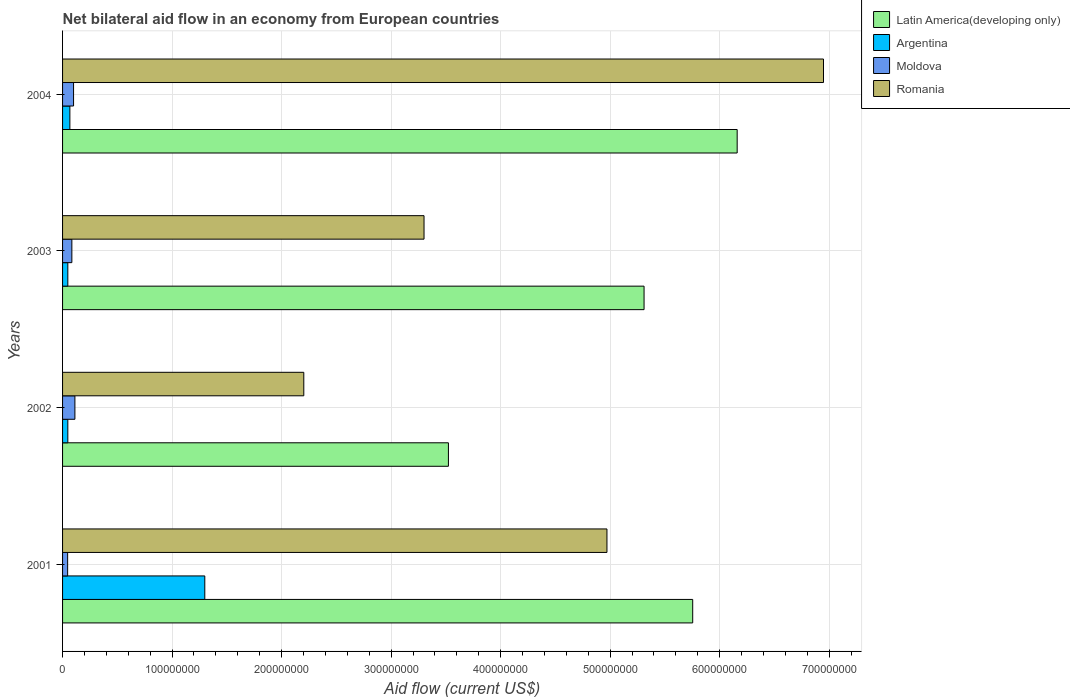How many groups of bars are there?
Offer a terse response. 4. Are the number of bars per tick equal to the number of legend labels?
Give a very brief answer. Yes. Are the number of bars on each tick of the Y-axis equal?
Offer a terse response. Yes. How many bars are there on the 1st tick from the top?
Give a very brief answer. 4. How many bars are there on the 3rd tick from the bottom?
Your answer should be compact. 4. In how many cases, is the number of bars for a given year not equal to the number of legend labels?
Make the answer very short. 0. What is the net bilateral aid flow in Romania in 2004?
Keep it short and to the point. 6.95e+08. Across all years, what is the maximum net bilateral aid flow in Romania?
Ensure brevity in your answer.  6.95e+08. Across all years, what is the minimum net bilateral aid flow in Moldova?
Ensure brevity in your answer.  4.64e+06. In which year was the net bilateral aid flow in Argentina minimum?
Offer a very short reply. 2002. What is the total net bilateral aid flow in Romania in the graph?
Your answer should be very brief. 1.74e+09. What is the difference between the net bilateral aid flow in Latin America(developing only) in 2001 and that in 2004?
Ensure brevity in your answer.  -4.06e+07. What is the difference between the net bilateral aid flow in Latin America(developing only) in 2004 and the net bilateral aid flow in Moldova in 2003?
Your response must be concise. 6.07e+08. What is the average net bilateral aid flow in Moldova per year?
Your answer should be very brief. 8.61e+06. In the year 2003, what is the difference between the net bilateral aid flow in Romania and net bilateral aid flow in Moldova?
Give a very brief answer. 3.22e+08. In how many years, is the net bilateral aid flow in Argentina greater than 560000000 US$?
Make the answer very short. 0. What is the ratio of the net bilateral aid flow in Argentina in 2002 to that in 2004?
Your response must be concise. 0.72. Is the net bilateral aid flow in Moldova in 2001 less than that in 2002?
Your answer should be compact. Yes. What is the difference between the highest and the second highest net bilateral aid flow in Latin America(developing only)?
Offer a very short reply. 4.06e+07. What is the difference between the highest and the lowest net bilateral aid flow in Moldova?
Make the answer very short. 6.63e+06. In how many years, is the net bilateral aid flow in Moldova greater than the average net bilateral aid flow in Moldova taken over all years?
Offer a terse response. 2. Is the sum of the net bilateral aid flow in Moldova in 2001 and 2003 greater than the maximum net bilateral aid flow in Romania across all years?
Offer a very short reply. No. What does the 2nd bar from the top in 2003 represents?
Your answer should be very brief. Moldova. What does the 3rd bar from the bottom in 2003 represents?
Keep it short and to the point. Moldova. Does the graph contain any zero values?
Make the answer very short. No. How are the legend labels stacked?
Your answer should be very brief. Vertical. What is the title of the graph?
Your answer should be very brief. Net bilateral aid flow in an economy from European countries. Does "Middle East & North Africa (developing only)" appear as one of the legend labels in the graph?
Offer a terse response. No. What is the label or title of the Y-axis?
Provide a short and direct response. Years. What is the Aid flow (current US$) in Latin America(developing only) in 2001?
Give a very brief answer. 5.75e+08. What is the Aid flow (current US$) of Argentina in 2001?
Your answer should be very brief. 1.30e+08. What is the Aid flow (current US$) of Moldova in 2001?
Make the answer very short. 4.64e+06. What is the Aid flow (current US$) in Romania in 2001?
Offer a terse response. 4.97e+08. What is the Aid flow (current US$) in Latin America(developing only) in 2002?
Your answer should be compact. 3.52e+08. What is the Aid flow (current US$) of Argentina in 2002?
Offer a very short reply. 4.80e+06. What is the Aid flow (current US$) in Moldova in 2002?
Provide a short and direct response. 1.13e+07. What is the Aid flow (current US$) of Romania in 2002?
Your response must be concise. 2.20e+08. What is the Aid flow (current US$) of Latin America(developing only) in 2003?
Provide a short and direct response. 5.31e+08. What is the Aid flow (current US$) in Argentina in 2003?
Ensure brevity in your answer.  4.81e+06. What is the Aid flow (current US$) in Moldova in 2003?
Provide a short and direct response. 8.48e+06. What is the Aid flow (current US$) in Romania in 2003?
Your answer should be very brief. 3.30e+08. What is the Aid flow (current US$) of Latin America(developing only) in 2004?
Offer a terse response. 6.16e+08. What is the Aid flow (current US$) in Argentina in 2004?
Provide a succinct answer. 6.68e+06. What is the Aid flow (current US$) of Moldova in 2004?
Keep it short and to the point. 1.00e+07. What is the Aid flow (current US$) in Romania in 2004?
Offer a terse response. 6.95e+08. Across all years, what is the maximum Aid flow (current US$) of Latin America(developing only)?
Offer a terse response. 6.16e+08. Across all years, what is the maximum Aid flow (current US$) of Argentina?
Ensure brevity in your answer.  1.30e+08. Across all years, what is the maximum Aid flow (current US$) of Moldova?
Make the answer very short. 1.13e+07. Across all years, what is the maximum Aid flow (current US$) in Romania?
Ensure brevity in your answer.  6.95e+08. Across all years, what is the minimum Aid flow (current US$) of Latin America(developing only)?
Make the answer very short. 3.52e+08. Across all years, what is the minimum Aid flow (current US$) of Argentina?
Give a very brief answer. 4.80e+06. Across all years, what is the minimum Aid flow (current US$) in Moldova?
Make the answer very short. 4.64e+06. Across all years, what is the minimum Aid flow (current US$) in Romania?
Offer a very short reply. 2.20e+08. What is the total Aid flow (current US$) in Latin America(developing only) in the graph?
Give a very brief answer. 2.07e+09. What is the total Aid flow (current US$) of Argentina in the graph?
Make the answer very short. 1.46e+08. What is the total Aid flow (current US$) of Moldova in the graph?
Your answer should be compact. 3.44e+07. What is the total Aid flow (current US$) of Romania in the graph?
Ensure brevity in your answer.  1.74e+09. What is the difference between the Aid flow (current US$) in Latin America(developing only) in 2001 and that in 2002?
Keep it short and to the point. 2.23e+08. What is the difference between the Aid flow (current US$) in Argentina in 2001 and that in 2002?
Offer a very short reply. 1.25e+08. What is the difference between the Aid flow (current US$) in Moldova in 2001 and that in 2002?
Provide a short and direct response. -6.63e+06. What is the difference between the Aid flow (current US$) of Romania in 2001 and that in 2002?
Give a very brief answer. 2.77e+08. What is the difference between the Aid flow (current US$) in Latin America(developing only) in 2001 and that in 2003?
Give a very brief answer. 4.44e+07. What is the difference between the Aid flow (current US$) in Argentina in 2001 and that in 2003?
Offer a terse response. 1.25e+08. What is the difference between the Aid flow (current US$) of Moldova in 2001 and that in 2003?
Your response must be concise. -3.84e+06. What is the difference between the Aid flow (current US$) in Romania in 2001 and that in 2003?
Your response must be concise. 1.67e+08. What is the difference between the Aid flow (current US$) in Latin America(developing only) in 2001 and that in 2004?
Your answer should be very brief. -4.06e+07. What is the difference between the Aid flow (current US$) of Argentina in 2001 and that in 2004?
Offer a very short reply. 1.23e+08. What is the difference between the Aid flow (current US$) of Moldova in 2001 and that in 2004?
Your answer should be very brief. -5.40e+06. What is the difference between the Aid flow (current US$) in Romania in 2001 and that in 2004?
Give a very brief answer. -1.98e+08. What is the difference between the Aid flow (current US$) of Latin America(developing only) in 2002 and that in 2003?
Provide a succinct answer. -1.79e+08. What is the difference between the Aid flow (current US$) of Moldova in 2002 and that in 2003?
Your answer should be compact. 2.79e+06. What is the difference between the Aid flow (current US$) of Romania in 2002 and that in 2003?
Ensure brevity in your answer.  -1.10e+08. What is the difference between the Aid flow (current US$) of Latin America(developing only) in 2002 and that in 2004?
Make the answer very short. -2.64e+08. What is the difference between the Aid flow (current US$) of Argentina in 2002 and that in 2004?
Give a very brief answer. -1.88e+06. What is the difference between the Aid flow (current US$) of Moldova in 2002 and that in 2004?
Offer a terse response. 1.23e+06. What is the difference between the Aid flow (current US$) of Romania in 2002 and that in 2004?
Keep it short and to the point. -4.75e+08. What is the difference between the Aid flow (current US$) in Latin America(developing only) in 2003 and that in 2004?
Your answer should be compact. -8.50e+07. What is the difference between the Aid flow (current US$) of Argentina in 2003 and that in 2004?
Provide a short and direct response. -1.87e+06. What is the difference between the Aid flow (current US$) of Moldova in 2003 and that in 2004?
Your answer should be very brief. -1.56e+06. What is the difference between the Aid flow (current US$) of Romania in 2003 and that in 2004?
Make the answer very short. -3.65e+08. What is the difference between the Aid flow (current US$) in Latin America(developing only) in 2001 and the Aid flow (current US$) in Argentina in 2002?
Offer a terse response. 5.71e+08. What is the difference between the Aid flow (current US$) in Latin America(developing only) in 2001 and the Aid flow (current US$) in Moldova in 2002?
Ensure brevity in your answer.  5.64e+08. What is the difference between the Aid flow (current US$) of Latin America(developing only) in 2001 and the Aid flow (current US$) of Romania in 2002?
Your answer should be very brief. 3.55e+08. What is the difference between the Aid flow (current US$) in Argentina in 2001 and the Aid flow (current US$) in Moldova in 2002?
Keep it short and to the point. 1.19e+08. What is the difference between the Aid flow (current US$) in Argentina in 2001 and the Aid flow (current US$) in Romania in 2002?
Your answer should be compact. -9.04e+07. What is the difference between the Aid flow (current US$) of Moldova in 2001 and the Aid flow (current US$) of Romania in 2002?
Offer a terse response. -2.16e+08. What is the difference between the Aid flow (current US$) of Latin America(developing only) in 2001 and the Aid flow (current US$) of Argentina in 2003?
Provide a short and direct response. 5.71e+08. What is the difference between the Aid flow (current US$) in Latin America(developing only) in 2001 and the Aid flow (current US$) in Moldova in 2003?
Your response must be concise. 5.67e+08. What is the difference between the Aid flow (current US$) in Latin America(developing only) in 2001 and the Aid flow (current US$) in Romania in 2003?
Your response must be concise. 2.45e+08. What is the difference between the Aid flow (current US$) of Argentina in 2001 and the Aid flow (current US$) of Moldova in 2003?
Give a very brief answer. 1.21e+08. What is the difference between the Aid flow (current US$) in Argentina in 2001 and the Aid flow (current US$) in Romania in 2003?
Provide a succinct answer. -2.00e+08. What is the difference between the Aid flow (current US$) of Moldova in 2001 and the Aid flow (current US$) of Romania in 2003?
Give a very brief answer. -3.25e+08. What is the difference between the Aid flow (current US$) of Latin America(developing only) in 2001 and the Aid flow (current US$) of Argentina in 2004?
Your answer should be compact. 5.69e+08. What is the difference between the Aid flow (current US$) in Latin America(developing only) in 2001 and the Aid flow (current US$) in Moldova in 2004?
Ensure brevity in your answer.  5.65e+08. What is the difference between the Aid flow (current US$) of Latin America(developing only) in 2001 and the Aid flow (current US$) of Romania in 2004?
Provide a short and direct response. -1.19e+08. What is the difference between the Aid flow (current US$) of Argentina in 2001 and the Aid flow (current US$) of Moldova in 2004?
Provide a short and direct response. 1.20e+08. What is the difference between the Aid flow (current US$) of Argentina in 2001 and the Aid flow (current US$) of Romania in 2004?
Offer a very short reply. -5.65e+08. What is the difference between the Aid flow (current US$) of Moldova in 2001 and the Aid flow (current US$) of Romania in 2004?
Your answer should be compact. -6.90e+08. What is the difference between the Aid flow (current US$) of Latin America(developing only) in 2002 and the Aid flow (current US$) of Argentina in 2003?
Provide a succinct answer. 3.48e+08. What is the difference between the Aid flow (current US$) in Latin America(developing only) in 2002 and the Aid flow (current US$) in Moldova in 2003?
Keep it short and to the point. 3.44e+08. What is the difference between the Aid flow (current US$) in Latin America(developing only) in 2002 and the Aid flow (current US$) in Romania in 2003?
Provide a short and direct response. 2.23e+07. What is the difference between the Aid flow (current US$) of Argentina in 2002 and the Aid flow (current US$) of Moldova in 2003?
Ensure brevity in your answer.  -3.68e+06. What is the difference between the Aid flow (current US$) in Argentina in 2002 and the Aid flow (current US$) in Romania in 2003?
Your answer should be compact. -3.25e+08. What is the difference between the Aid flow (current US$) of Moldova in 2002 and the Aid flow (current US$) of Romania in 2003?
Give a very brief answer. -3.19e+08. What is the difference between the Aid flow (current US$) in Latin America(developing only) in 2002 and the Aid flow (current US$) in Argentina in 2004?
Your answer should be compact. 3.46e+08. What is the difference between the Aid flow (current US$) of Latin America(developing only) in 2002 and the Aid flow (current US$) of Moldova in 2004?
Make the answer very short. 3.42e+08. What is the difference between the Aid flow (current US$) of Latin America(developing only) in 2002 and the Aid flow (current US$) of Romania in 2004?
Offer a very short reply. -3.42e+08. What is the difference between the Aid flow (current US$) in Argentina in 2002 and the Aid flow (current US$) in Moldova in 2004?
Keep it short and to the point. -5.24e+06. What is the difference between the Aid flow (current US$) in Argentina in 2002 and the Aid flow (current US$) in Romania in 2004?
Make the answer very short. -6.90e+08. What is the difference between the Aid flow (current US$) of Moldova in 2002 and the Aid flow (current US$) of Romania in 2004?
Make the answer very short. -6.84e+08. What is the difference between the Aid flow (current US$) of Latin America(developing only) in 2003 and the Aid flow (current US$) of Argentina in 2004?
Your answer should be compact. 5.24e+08. What is the difference between the Aid flow (current US$) of Latin America(developing only) in 2003 and the Aid flow (current US$) of Moldova in 2004?
Ensure brevity in your answer.  5.21e+08. What is the difference between the Aid flow (current US$) of Latin America(developing only) in 2003 and the Aid flow (current US$) of Romania in 2004?
Provide a succinct answer. -1.64e+08. What is the difference between the Aid flow (current US$) of Argentina in 2003 and the Aid flow (current US$) of Moldova in 2004?
Give a very brief answer. -5.23e+06. What is the difference between the Aid flow (current US$) of Argentina in 2003 and the Aid flow (current US$) of Romania in 2004?
Provide a succinct answer. -6.90e+08. What is the difference between the Aid flow (current US$) of Moldova in 2003 and the Aid flow (current US$) of Romania in 2004?
Keep it short and to the point. -6.86e+08. What is the average Aid flow (current US$) in Latin America(developing only) per year?
Provide a short and direct response. 5.19e+08. What is the average Aid flow (current US$) of Argentina per year?
Offer a terse response. 3.65e+07. What is the average Aid flow (current US$) in Moldova per year?
Your response must be concise. 8.61e+06. What is the average Aid flow (current US$) in Romania per year?
Give a very brief answer. 4.36e+08. In the year 2001, what is the difference between the Aid flow (current US$) of Latin America(developing only) and Aid flow (current US$) of Argentina?
Offer a terse response. 4.45e+08. In the year 2001, what is the difference between the Aid flow (current US$) in Latin America(developing only) and Aid flow (current US$) in Moldova?
Your answer should be very brief. 5.71e+08. In the year 2001, what is the difference between the Aid flow (current US$) in Latin America(developing only) and Aid flow (current US$) in Romania?
Ensure brevity in your answer.  7.83e+07. In the year 2001, what is the difference between the Aid flow (current US$) of Argentina and Aid flow (current US$) of Moldova?
Ensure brevity in your answer.  1.25e+08. In the year 2001, what is the difference between the Aid flow (current US$) in Argentina and Aid flow (current US$) in Romania?
Provide a succinct answer. -3.67e+08. In the year 2001, what is the difference between the Aid flow (current US$) in Moldova and Aid flow (current US$) in Romania?
Give a very brief answer. -4.92e+08. In the year 2002, what is the difference between the Aid flow (current US$) of Latin America(developing only) and Aid flow (current US$) of Argentina?
Provide a short and direct response. 3.48e+08. In the year 2002, what is the difference between the Aid flow (current US$) of Latin America(developing only) and Aid flow (current US$) of Moldova?
Keep it short and to the point. 3.41e+08. In the year 2002, what is the difference between the Aid flow (current US$) in Latin America(developing only) and Aid flow (current US$) in Romania?
Make the answer very short. 1.32e+08. In the year 2002, what is the difference between the Aid flow (current US$) of Argentina and Aid flow (current US$) of Moldova?
Offer a terse response. -6.47e+06. In the year 2002, what is the difference between the Aid flow (current US$) of Argentina and Aid flow (current US$) of Romania?
Your answer should be very brief. -2.15e+08. In the year 2002, what is the difference between the Aid flow (current US$) of Moldova and Aid flow (current US$) of Romania?
Provide a succinct answer. -2.09e+08. In the year 2003, what is the difference between the Aid flow (current US$) in Latin America(developing only) and Aid flow (current US$) in Argentina?
Ensure brevity in your answer.  5.26e+08. In the year 2003, what is the difference between the Aid flow (current US$) in Latin America(developing only) and Aid flow (current US$) in Moldova?
Give a very brief answer. 5.22e+08. In the year 2003, what is the difference between the Aid flow (current US$) of Latin America(developing only) and Aid flow (current US$) of Romania?
Offer a very short reply. 2.01e+08. In the year 2003, what is the difference between the Aid flow (current US$) in Argentina and Aid flow (current US$) in Moldova?
Your response must be concise. -3.67e+06. In the year 2003, what is the difference between the Aid flow (current US$) in Argentina and Aid flow (current US$) in Romania?
Provide a succinct answer. -3.25e+08. In the year 2003, what is the difference between the Aid flow (current US$) in Moldova and Aid flow (current US$) in Romania?
Keep it short and to the point. -3.22e+08. In the year 2004, what is the difference between the Aid flow (current US$) of Latin America(developing only) and Aid flow (current US$) of Argentina?
Provide a short and direct response. 6.09e+08. In the year 2004, what is the difference between the Aid flow (current US$) of Latin America(developing only) and Aid flow (current US$) of Moldova?
Give a very brief answer. 6.06e+08. In the year 2004, what is the difference between the Aid flow (current US$) of Latin America(developing only) and Aid flow (current US$) of Romania?
Your answer should be very brief. -7.88e+07. In the year 2004, what is the difference between the Aid flow (current US$) in Argentina and Aid flow (current US$) in Moldova?
Keep it short and to the point. -3.36e+06. In the year 2004, what is the difference between the Aid flow (current US$) of Argentina and Aid flow (current US$) of Romania?
Give a very brief answer. -6.88e+08. In the year 2004, what is the difference between the Aid flow (current US$) of Moldova and Aid flow (current US$) of Romania?
Your answer should be compact. -6.85e+08. What is the ratio of the Aid flow (current US$) in Latin America(developing only) in 2001 to that in 2002?
Your answer should be very brief. 1.63. What is the ratio of the Aid flow (current US$) of Argentina in 2001 to that in 2002?
Offer a very short reply. 27.06. What is the ratio of the Aid flow (current US$) in Moldova in 2001 to that in 2002?
Provide a succinct answer. 0.41. What is the ratio of the Aid flow (current US$) in Romania in 2001 to that in 2002?
Keep it short and to the point. 2.26. What is the ratio of the Aid flow (current US$) of Latin America(developing only) in 2001 to that in 2003?
Make the answer very short. 1.08. What is the ratio of the Aid flow (current US$) in Argentina in 2001 to that in 2003?
Your response must be concise. 27. What is the ratio of the Aid flow (current US$) of Moldova in 2001 to that in 2003?
Your answer should be compact. 0.55. What is the ratio of the Aid flow (current US$) of Romania in 2001 to that in 2003?
Offer a terse response. 1.51. What is the ratio of the Aid flow (current US$) of Latin America(developing only) in 2001 to that in 2004?
Ensure brevity in your answer.  0.93. What is the ratio of the Aid flow (current US$) in Argentina in 2001 to that in 2004?
Ensure brevity in your answer.  19.44. What is the ratio of the Aid flow (current US$) in Moldova in 2001 to that in 2004?
Your response must be concise. 0.46. What is the ratio of the Aid flow (current US$) of Romania in 2001 to that in 2004?
Offer a terse response. 0.72. What is the ratio of the Aid flow (current US$) of Latin America(developing only) in 2002 to that in 2003?
Make the answer very short. 0.66. What is the ratio of the Aid flow (current US$) of Argentina in 2002 to that in 2003?
Provide a succinct answer. 1. What is the ratio of the Aid flow (current US$) in Moldova in 2002 to that in 2003?
Ensure brevity in your answer.  1.33. What is the ratio of the Aid flow (current US$) in Romania in 2002 to that in 2003?
Give a very brief answer. 0.67. What is the ratio of the Aid flow (current US$) in Latin America(developing only) in 2002 to that in 2004?
Provide a short and direct response. 0.57. What is the ratio of the Aid flow (current US$) in Argentina in 2002 to that in 2004?
Make the answer very short. 0.72. What is the ratio of the Aid flow (current US$) in Moldova in 2002 to that in 2004?
Your answer should be compact. 1.12. What is the ratio of the Aid flow (current US$) in Romania in 2002 to that in 2004?
Your answer should be compact. 0.32. What is the ratio of the Aid flow (current US$) in Latin America(developing only) in 2003 to that in 2004?
Your answer should be very brief. 0.86. What is the ratio of the Aid flow (current US$) in Argentina in 2003 to that in 2004?
Give a very brief answer. 0.72. What is the ratio of the Aid flow (current US$) of Moldova in 2003 to that in 2004?
Offer a very short reply. 0.84. What is the ratio of the Aid flow (current US$) in Romania in 2003 to that in 2004?
Ensure brevity in your answer.  0.47. What is the difference between the highest and the second highest Aid flow (current US$) of Latin America(developing only)?
Provide a short and direct response. 4.06e+07. What is the difference between the highest and the second highest Aid flow (current US$) in Argentina?
Ensure brevity in your answer.  1.23e+08. What is the difference between the highest and the second highest Aid flow (current US$) in Moldova?
Provide a succinct answer. 1.23e+06. What is the difference between the highest and the second highest Aid flow (current US$) of Romania?
Your response must be concise. 1.98e+08. What is the difference between the highest and the lowest Aid flow (current US$) of Latin America(developing only)?
Make the answer very short. 2.64e+08. What is the difference between the highest and the lowest Aid flow (current US$) of Argentina?
Your answer should be compact. 1.25e+08. What is the difference between the highest and the lowest Aid flow (current US$) in Moldova?
Provide a succinct answer. 6.63e+06. What is the difference between the highest and the lowest Aid flow (current US$) in Romania?
Keep it short and to the point. 4.75e+08. 